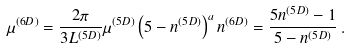<formula> <loc_0><loc_0><loc_500><loc_500>\mu ^ { ( 6 D ) } = \frac { 2 \pi } { 3 L ^ { ( 5 D ) } } \mu ^ { ( 5 D ) } \left ( 5 - n ^ { ( 5 D ) } \right ) ^ { a } n ^ { ( 6 D ) } = \frac { 5 n ^ { ( 5 D ) } - 1 } { 5 - n ^ { ( 5 D ) } } \, .</formula> 